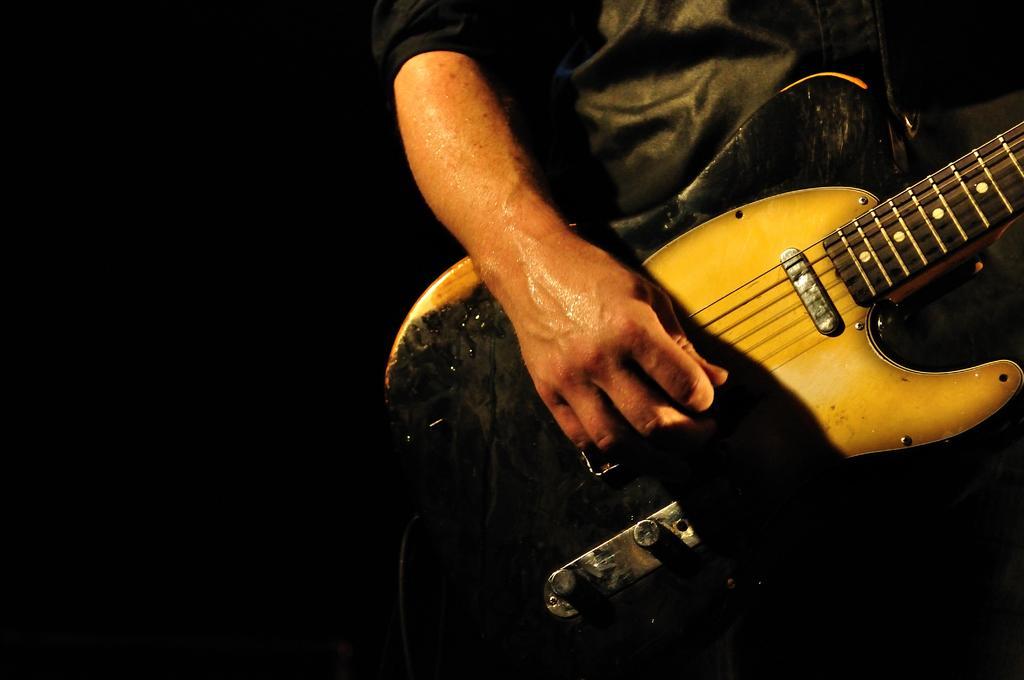Describe this image in one or two sentences. This person holding guitar. 